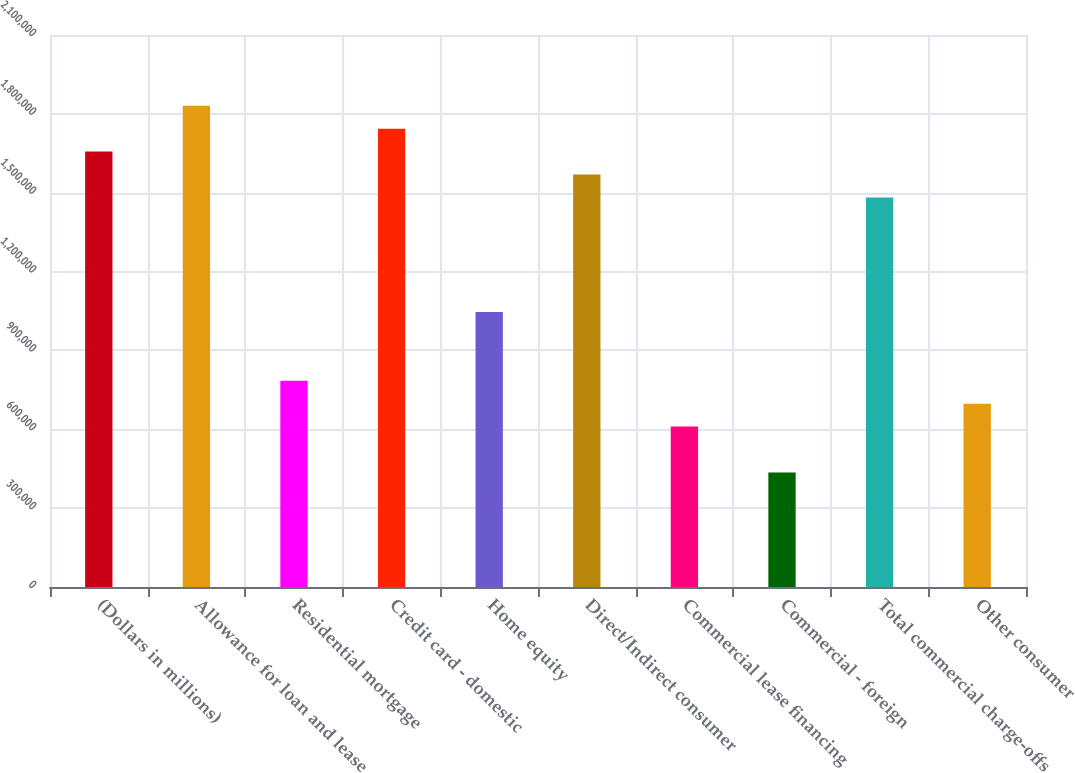<chart> <loc_0><loc_0><loc_500><loc_500><bar_chart><fcel>(Dollars in millions)<fcel>Allowance for loan and lease<fcel>Residential mortgage<fcel>Credit card - domestic<fcel>Home equity<fcel>Direct/Indirect consumer<fcel>Commercial lease financing<fcel>Commercial - foreign<fcel>Total commercial charge-offs<fcel>Other consumer<nl><fcel>1.65633e+06<fcel>1.83068e+06<fcel>784579<fcel>1.74351e+06<fcel>1.0461e+06<fcel>1.56916e+06<fcel>610228<fcel>435877<fcel>1.48198e+06<fcel>697403<nl></chart> 